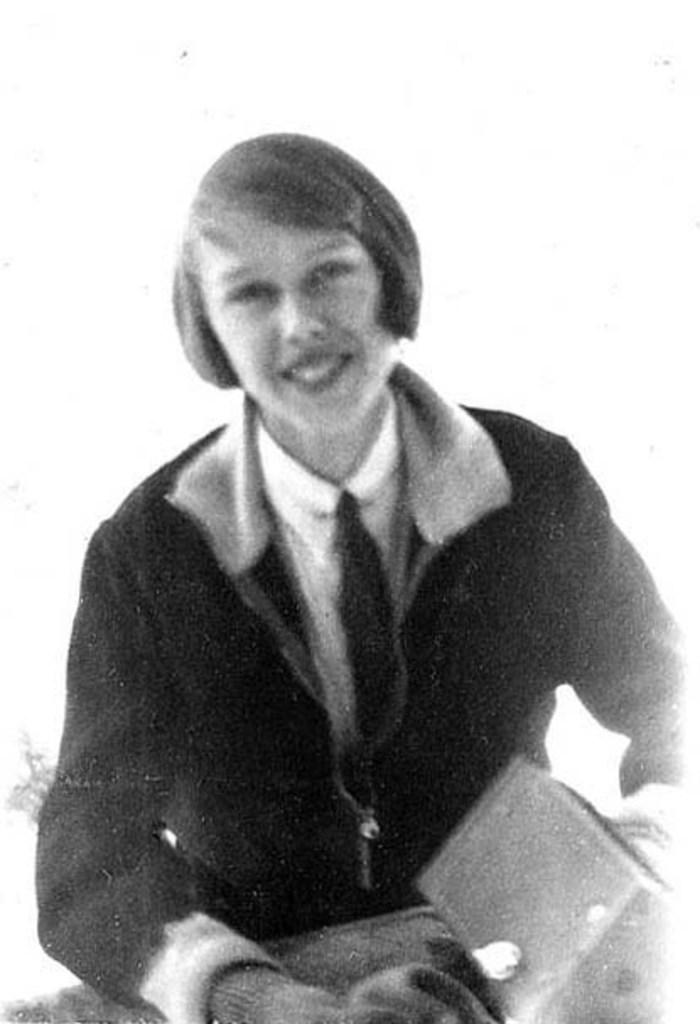What is the color scheme of the image? The image is black and white. Who is the main subject in the image? There is a girl in the image. What is the girl wearing? The girl is wearing a white shirt and a black jacket. What is the girl holding in her hand? The girl is holding a box in her hand. What is the girl's expression in the image? The girl is smiling. What is the color of the background in the image? The background of the image is white in color. What type of calendar is hanging on the wall in the image? There is no calendar present in the image; it is a black and white photograph of a girl. What is the girl's wish in the image? There is no indication of a wish in the image; the girl is simply smiling while holding a box. 